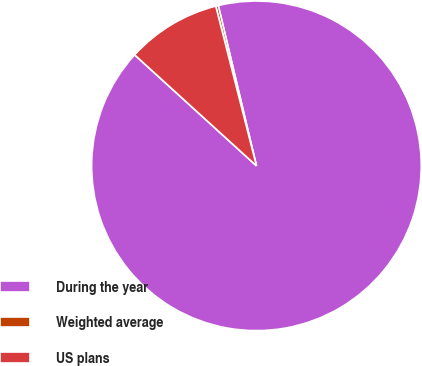Convert chart. <chart><loc_0><loc_0><loc_500><loc_500><pie_chart><fcel>During the year<fcel>Weighted average<fcel>US plans<nl><fcel>90.47%<fcel>0.25%<fcel>9.27%<nl></chart> 